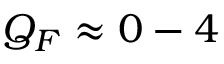Convert formula to latex. <formula><loc_0><loc_0><loc_500><loc_500>Q _ { F } \approx 0 - 4</formula> 